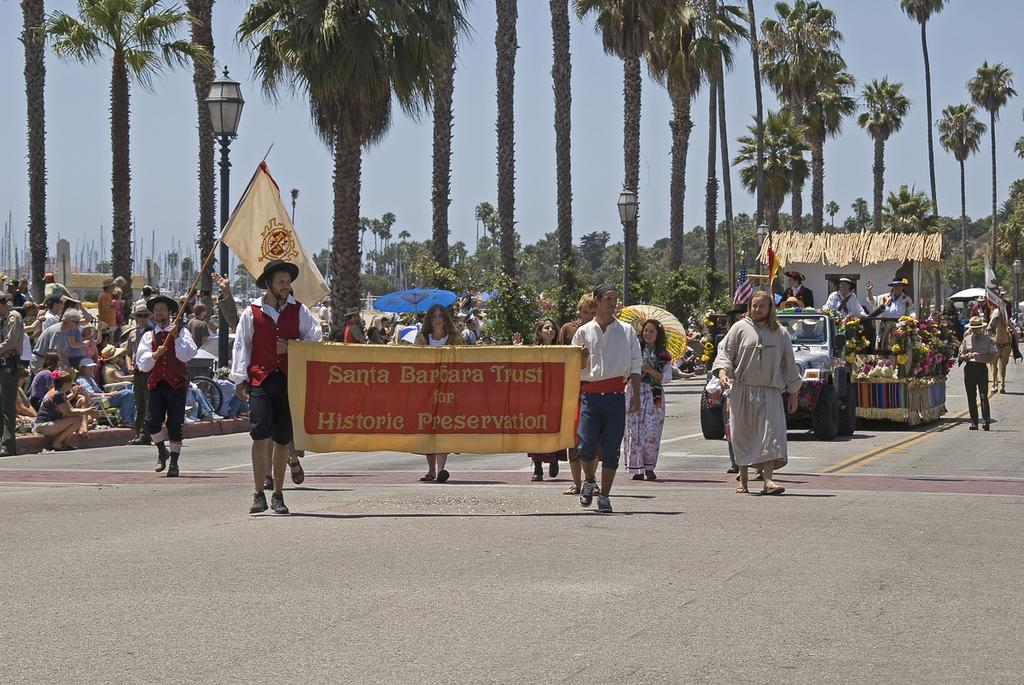How many people can be seen in the image? There are people in the image, but the exact number is not specified. What is one of the features of the landscape in the image? There is a road in the image. What type of decorations are present in the image? There are flags and a banner in the image. What objects might be used for protection from the elements? There are umbrellas in the image. What type of vehicle is visible in the image? There is a vehicle in the image. What type of flora can be seen in the image? There are flowers and trees in the image. What type of structures are present in the image? There are poles in the image. What type of illumination is visible in the image? There are lights in the image. What type of animal is present in the image? There is a horse in the image. What can be seen in the background of the image? The sky is visible in the background of the image. What word is written on the banner in the image? There is no specific word mentioned in the facts provided, so we cannot determine what word is written on the banner. Are there any army personnel visible in the image? There is no mention of any army personnel in the image, so we cannot confirm their presence. 